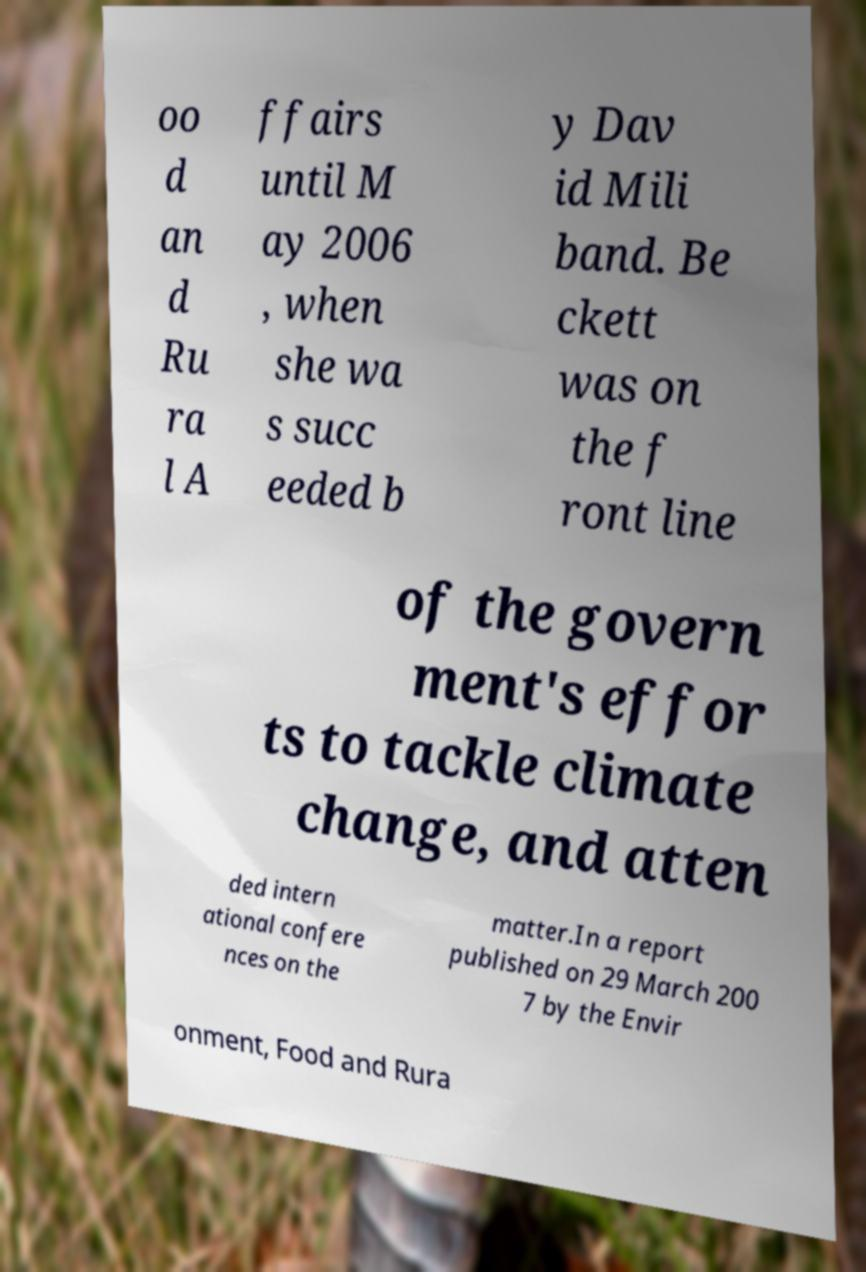There's text embedded in this image that I need extracted. Can you transcribe it verbatim? oo d an d Ru ra l A ffairs until M ay 2006 , when she wa s succ eeded b y Dav id Mili band. Be ckett was on the f ront line of the govern ment's effor ts to tackle climate change, and atten ded intern ational confere nces on the matter.In a report published on 29 March 200 7 by the Envir onment, Food and Rura 